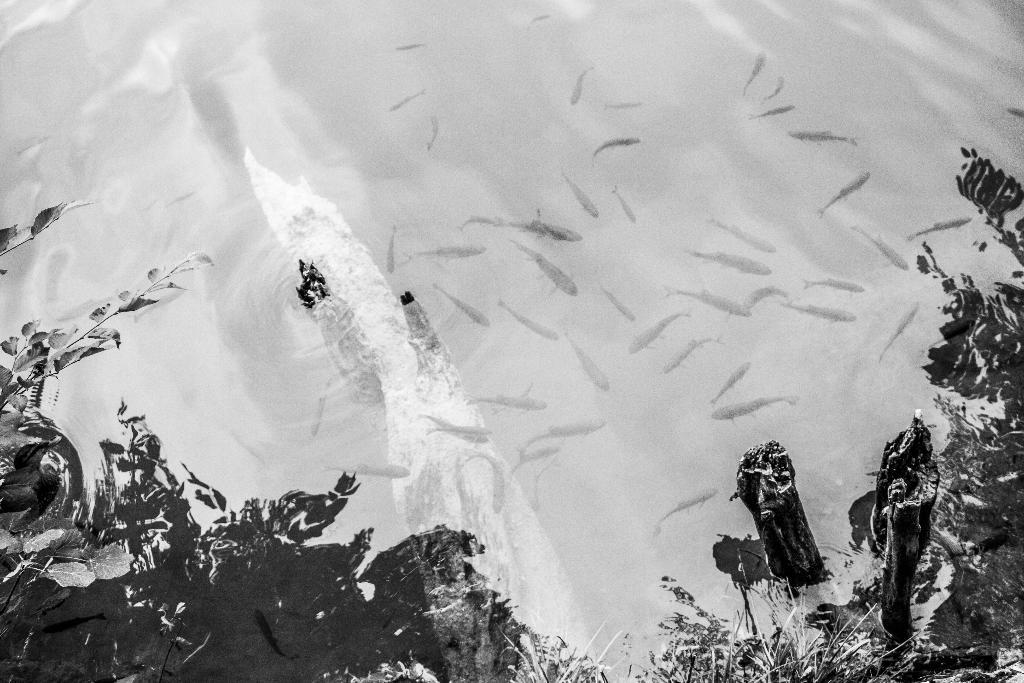What is the color scheme of the image? The image is black and white. What can be found at the bottom of the image? There are plants at the bottom of the image. What is happening in the water in the image? Many fishes are swimming in the water in the image. How does the tramp contribute to the image? There is no tramp present in the image. 